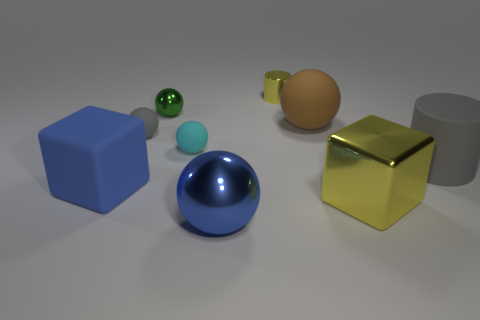Imagine if these objects were part of a children's game. What could be the rules? If these objects were part of a children's game, one could imagine a game of balance and strategy. The rules might be as follows: The goal is to stack as many objects as possible without the structure collapsing. Players take turns selecting an object to place on the stack. The rubber spheres can act as 'wild' objects with a risk—their bouncy texture could make the stack unstable, but if placed successfully, they could yield bonus points. The smooth brown egg might be a 'challenge' object, awkward to balance and with a high point value. The glossy blue sphere could be called the 'foundation' object, starting the game due to its stable base. Lastly, the metallic golden cube might be the 'keystone' piece, granting additional structural integrity but worth fewer points due to ease of placement. The game ends when the stack collapses, and the player with the highest score wins. 